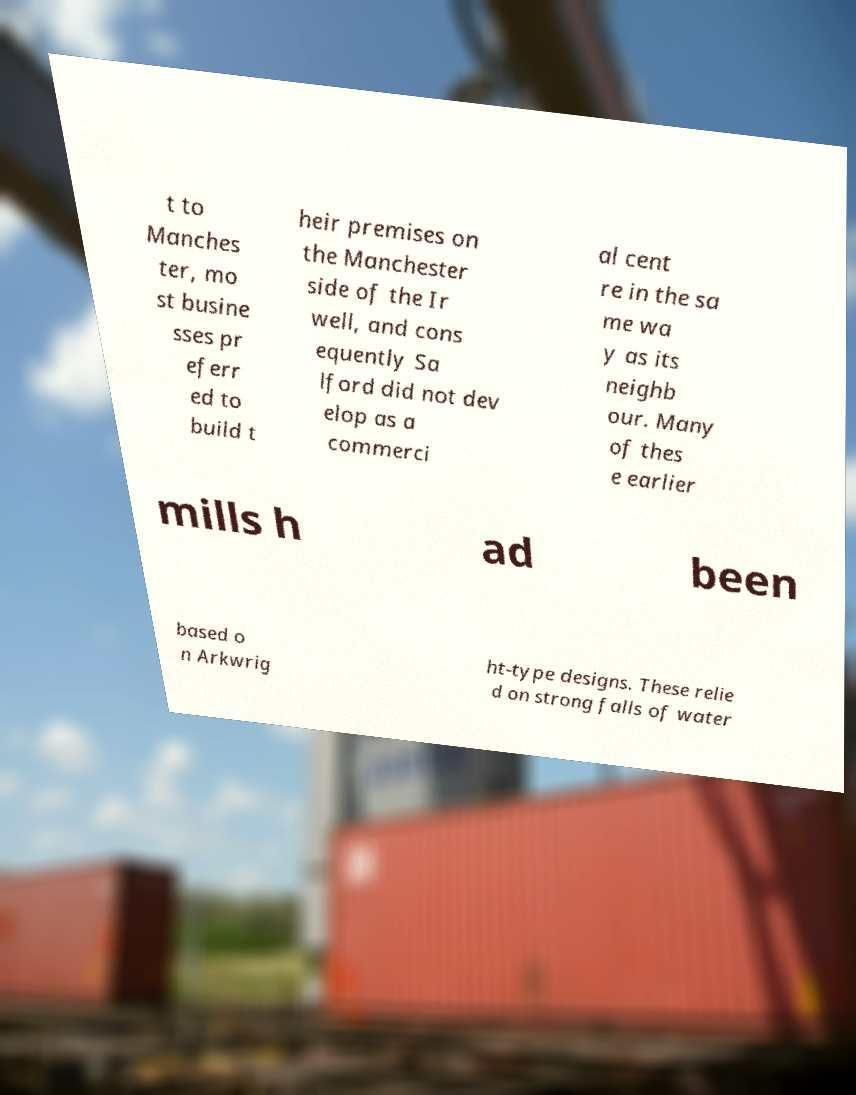Can you accurately transcribe the text from the provided image for me? t to Manches ter, mo st busine sses pr eferr ed to build t heir premises on the Manchester side of the Ir well, and cons equently Sa lford did not dev elop as a commerci al cent re in the sa me wa y as its neighb our. Many of thes e earlier mills h ad been based o n Arkwrig ht-type designs. These relie d on strong falls of water 